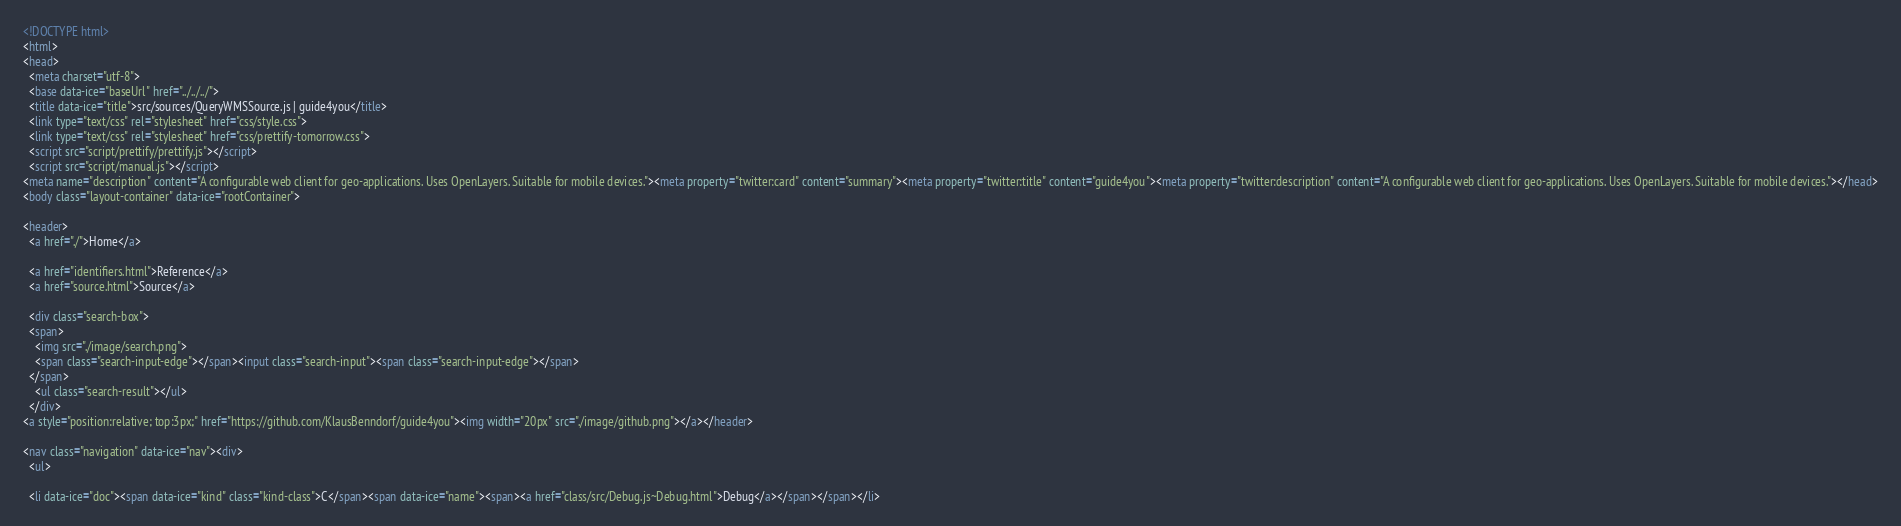Convert code to text. <code><loc_0><loc_0><loc_500><loc_500><_HTML_><!DOCTYPE html>
<html>
<head>
  <meta charset="utf-8">
  <base data-ice="baseUrl" href="../../../">
  <title data-ice="title">src/sources/QueryWMSSource.js | guide4you</title>
  <link type="text/css" rel="stylesheet" href="css/style.css">
  <link type="text/css" rel="stylesheet" href="css/prettify-tomorrow.css">
  <script src="script/prettify/prettify.js"></script>
  <script src="script/manual.js"></script>
<meta name="description" content="A configurable web client for geo-applications. Uses OpenLayers. Suitable for mobile devices."><meta property="twitter:card" content="summary"><meta property="twitter:title" content="guide4you"><meta property="twitter:description" content="A configurable web client for geo-applications. Uses OpenLayers. Suitable for mobile devices."></head>
<body class="layout-container" data-ice="rootContainer">

<header>
  <a href="./">Home</a>
  
  <a href="identifiers.html">Reference</a>
  <a href="source.html">Source</a>
  
  <div class="search-box">
  <span>
    <img src="./image/search.png">
    <span class="search-input-edge"></span><input class="search-input"><span class="search-input-edge"></span>
  </span>
    <ul class="search-result"></ul>
  </div>
<a style="position:relative; top:3px;" href="https://github.com/KlausBenndorf/guide4you"><img width="20px" src="./image/github.png"></a></header>

<nav class="navigation" data-ice="nav"><div>
  <ul>
    
  <li data-ice="doc"><span data-ice="kind" class="kind-class">C</span><span data-ice="name"><span><a href="class/src/Debug.js~Debug.html">Debug</a></span></span></li></code> 